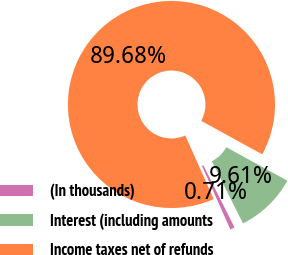Convert chart to OTSL. <chart><loc_0><loc_0><loc_500><loc_500><pie_chart><fcel>(In thousands)<fcel>Interest (including amounts<fcel>Income taxes net of refunds<nl><fcel>0.71%<fcel>9.61%<fcel>89.68%<nl></chart> 